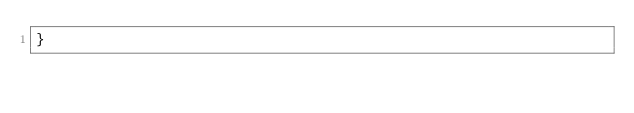<code> <loc_0><loc_0><loc_500><loc_500><_CSS_>}
</code> 